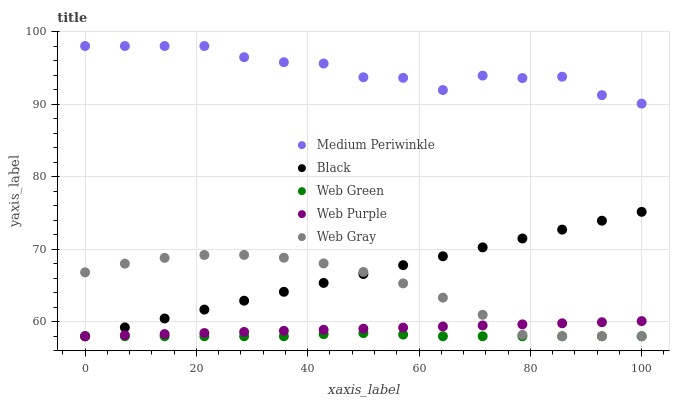Does Web Green have the minimum area under the curve?
Answer yes or no. Yes. Does Medium Periwinkle have the maximum area under the curve?
Answer yes or no. Yes. Does Web Purple have the minimum area under the curve?
Answer yes or no. No. Does Web Purple have the maximum area under the curve?
Answer yes or no. No. Is Web Purple the smoothest?
Answer yes or no. Yes. Is Medium Periwinkle the roughest?
Answer yes or no. Yes. Is Web Gray the smoothest?
Answer yes or no. No. Is Web Gray the roughest?
Answer yes or no. No. Does Black have the lowest value?
Answer yes or no. Yes. Does Medium Periwinkle have the lowest value?
Answer yes or no. No. Does Medium Periwinkle have the highest value?
Answer yes or no. Yes. Does Web Purple have the highest value?
Answer yes or no. No. Is Web Green less than Medium Periwinkle?
Answer yes or no. Yes. Is Medium Periwinkle greater than Web Gray?
Answer yes or no. Yes. Does Web Purple intersect Web Green?
Answer yes or no. Yes. Is Web Purple less than Web Green?
Answer yes or no. No. Is Web Purple greater than Web Green?
Answer yes or no. No. Does Web Green intersect Medium Periwinkle?
Answer yes or no. No. 